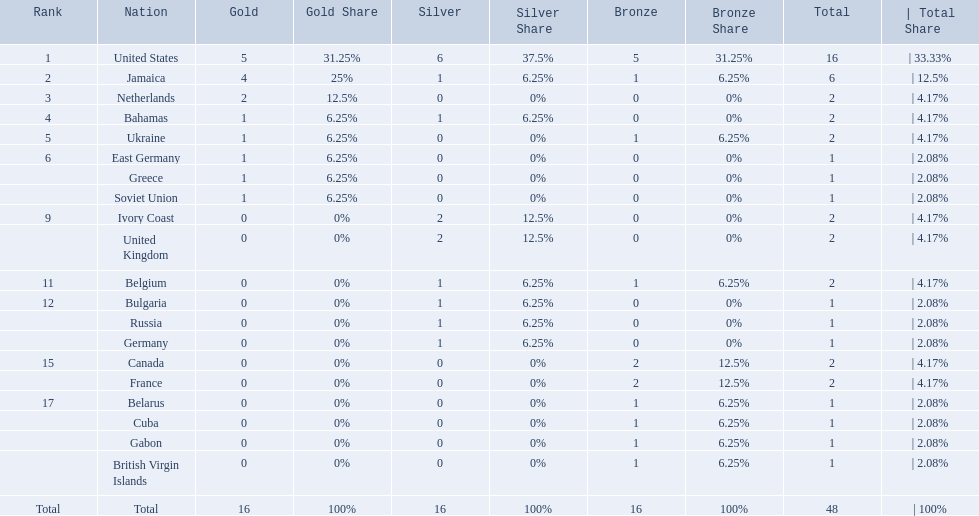Which countries participated? United States, Jamaica, Netherlands, Bahamas, Ukraine, East Germany, Greece, Soviet Union, Ivory Coast, United Kingdom, Belgium, Bulgaria, Russia, Germany, Canada, France, Belarus, Cuba, Gabon, British Virgin Islands. How many gold medals were won by each? 5, 4, 2, 1, 1, 1, 1, 1, 0, 0, 0, 0, 0, 0, 0, 0, 0, 0, 0, 0. And which country won the most? United States. 